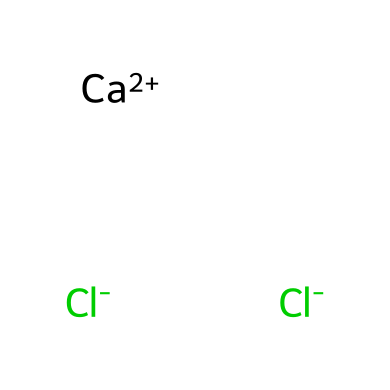What is the total number of ions in this compound? The SMILES representation indicates there is one calcium ion (Ca+2) and two chloride ions (Cl-). Adding these gives a total of three ions.
Answer: three How many chloride ions are present in this formula? The SMILES notation shows two chloride ions (Cl-), as indicated by the two instances of Cl-.
Answer: two What is the charge on the calcium ion in this compound? The SMILES notation specifies the calcium ion as Ca+2, denoting a charge of positive two.
Answer: +2 Is this compound ionic or covalent? The presence of charged ions (Ca+2 and Cl-) indicates that the compound forms through ionic bonds, characteristic of ionic compounds.
Answer: ionic What role does calcium chloride play when used for de-icing? Calcium chloride dissociates into its ions in solution, lowering the freezing point of water, which aids in ice melting.
Answer: de-icer How many total atoms are in the compound of calcium chloride? The compound has one calcium atom and two chlorine atoms, resulting in a total of three atoms.
Answer: three 